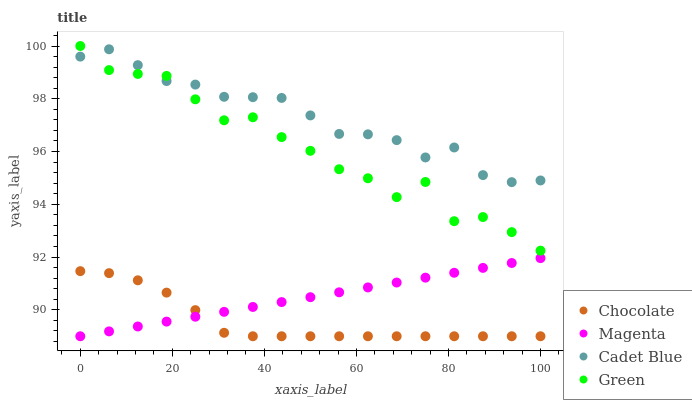Does Chocolate have the minimum area under the curve?
Answer yes or no. Yes. Does Cadet Blue have the maximum area under the curve?
Answer yes or no. Yes. Does Green have the minimum area under the curve?
Answer yes or no. No. Does Green have the maximum area under the curve?
Answer yes or no. No. Is Magenta the smoothest?
Answer yes or no. Yes. Is Green the roughest?
Answer yes or no. Yes. Is Cadet Blue the smoothest?
Answer yes or no. No. Is Cadet Blue the roughest?
Answer yes or no. No. Does Magenta have the lowest value?
Answer yes or no. Yes. Does Green have the lowest value?
Answer yes or no. No. Does Green have the highest value?
Answer yes or no. Yes. Does Cadet Blue have the highest value?
Answer yes or no. No. Is Magenta less than Green?
Answer yes or no. Yes. Is Cadet Blue greater than Magenta?
Answer yes or no. Yes. Does Green intersect Cadet Blue?
Answer yes or no. Yes. Is Green less than Cadet Blue?
Answer yes or no. No. Is Green greater than Cadet Blue?
Answer yes or no. No. Does Magenta intersect Green?
Answer yes or no. No. 